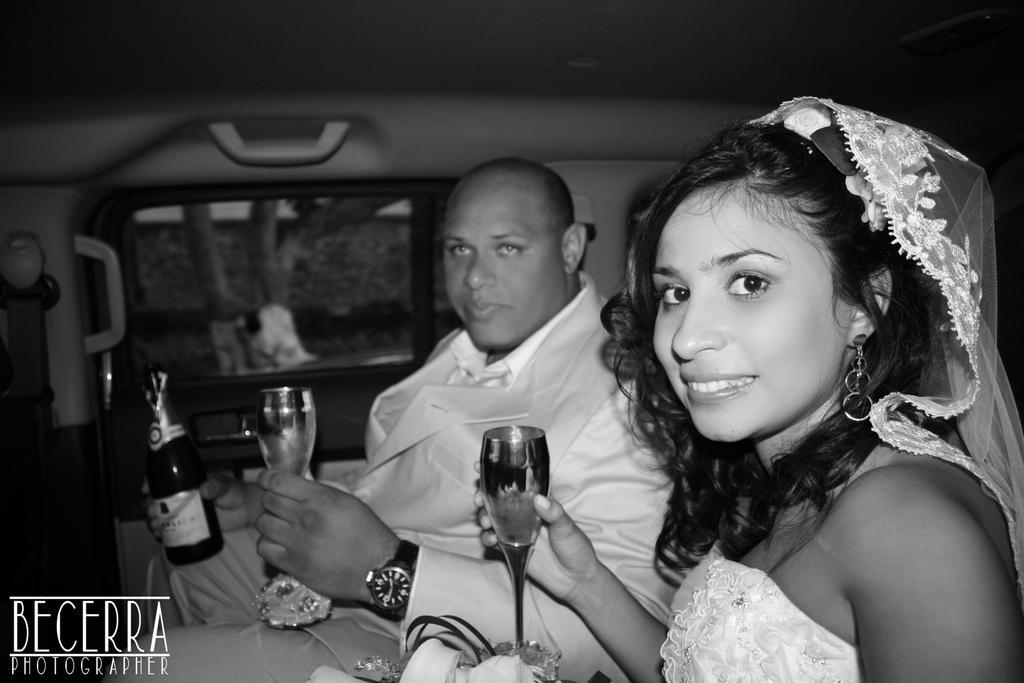Can you describe this image briefly? A man and a woman are sitting inside a vehicle. They are holding glasses, the man is holding a bottle. The lady is smiling. 